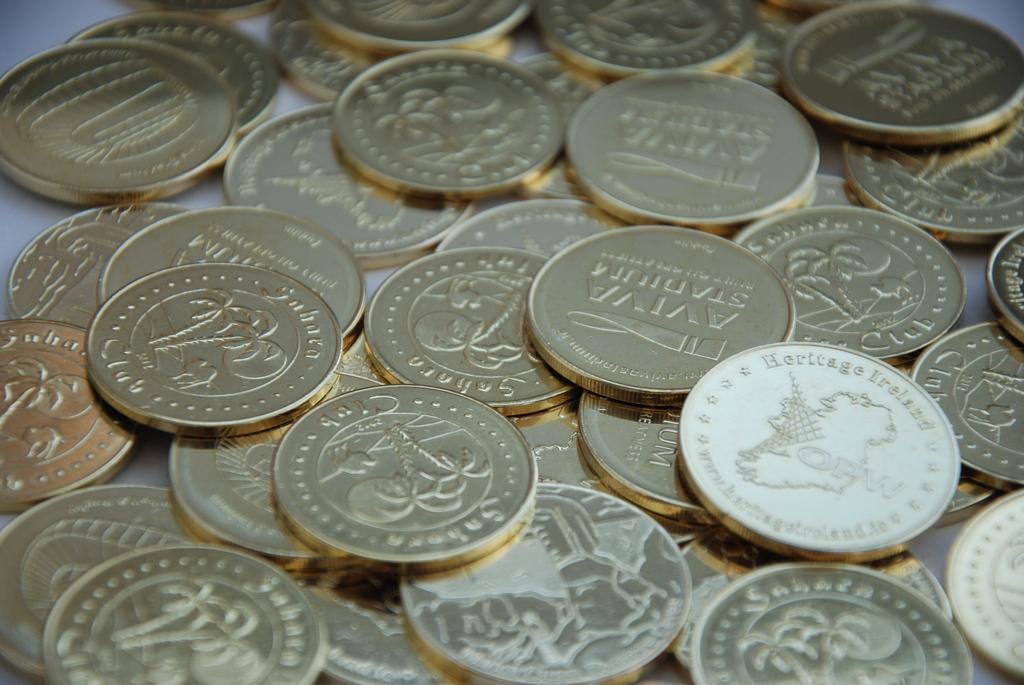Please provide a concise description of this image. In this image there are coins on the surface that looks like a table, there is text on the coins, there is a tree on the coins, there is an animal on the coins, at the background of the image there is an object that looks like a table. 